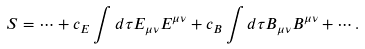Convert formula to latex. <formula><loc_0><loc_0><loc_500><loc_500>S = \cdots + c _ { E } \int d \tau E _ { \mu \nu } E ^ { \mu \nu } + c _ { B } \int d \tau B _ { \mu \nu } B ^ { \mu \nu } + \cdots .</formula> 